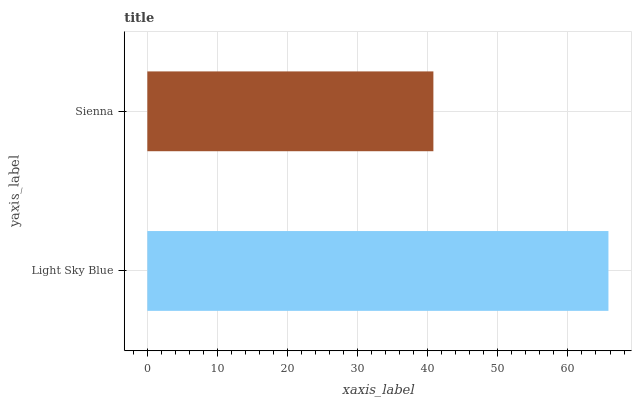Is Sienna the minimum?
Answer yes or no. Yes. Is Light Sky Blue the maximum?
Answer yes or no. Yes. Is Sienna the maximum?
Answer yes or no. No. Is Light Sky Blue greater than Sienna?
Answer yes or no. Yes. Is Sienna less than Light Sky Blue?
Answer yes or no. Yes. Is Sienna greater than Light Sky Blue?
Answer yes or no. No. Is Light Sky Blue less than Sienna?
Answer yes or no. No. Is Light Sky Blue the high median?
Answer yes or no. Yes. Is Sienna the low median?
Answer yes or no. Yes. Is Sienna the high median?
Answer yes or no. No. Is Light Sky Blue the low median?
Answer yes or no. No. 